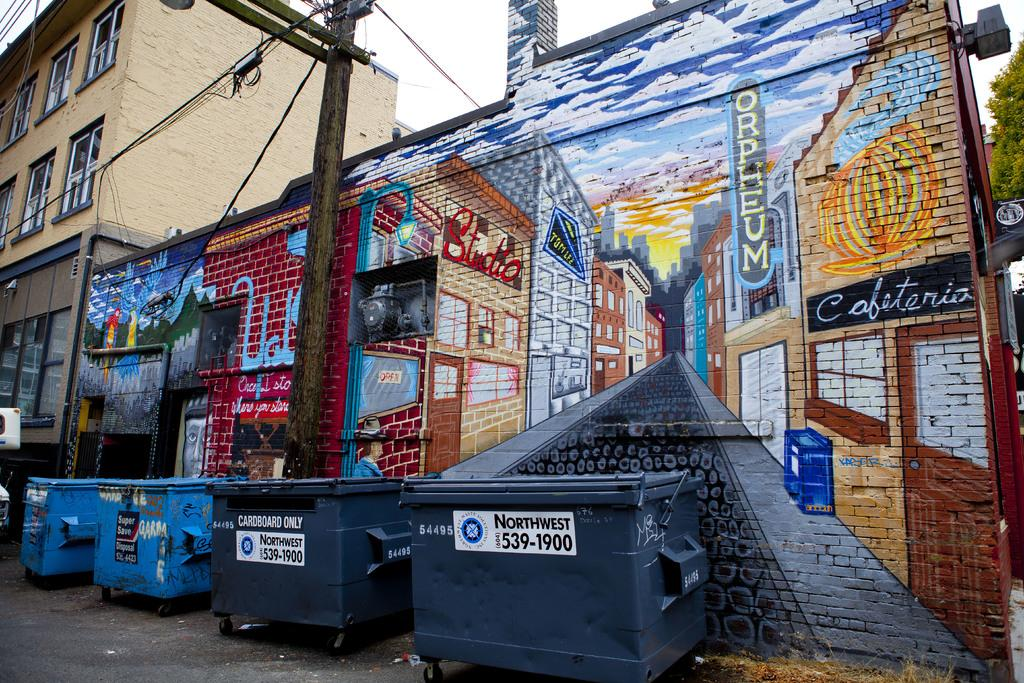Provide a one-sentence caption for the provided image. a mural advertising Orpheum and a cafeteria is lined with dumpsters. 